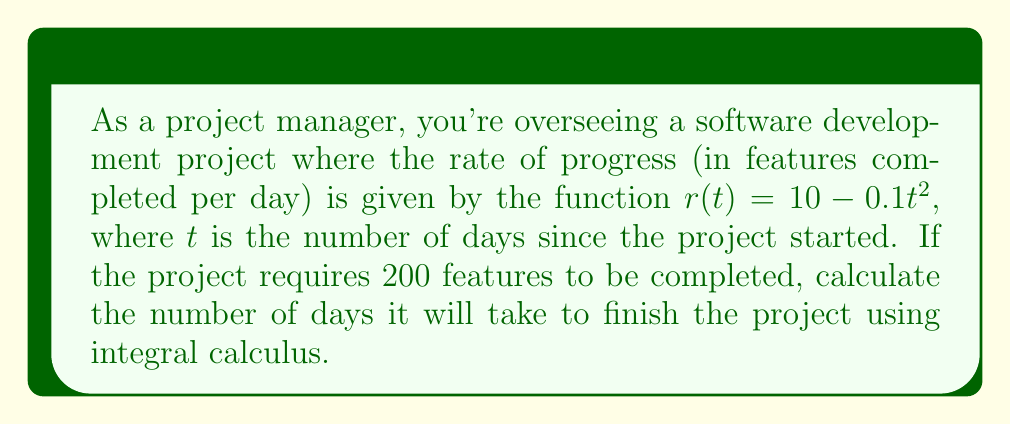Solve this math problem. To solve this problem, we need to use integral calculus to find the total number of features completed over time and then determine when this total reaches 200.

1. The rate of progress is given by $r(t) = 10 - 0.1t^2$ features per day.

2. To find the total number of features completed up to time $T$, we need to integrate the rate function from 0 to T:

   $$F(T) = \int_0^T r(t) dt = \int_0^T (10 - 0.1t^2) dt$$

3. Integrating this function:

   $$F(T) = [10t - \frac{0.1t^3}{3}]_0^T = 10T - \frac{0.1T^3}{3}$$

4. We want to find T when F(T) = 200:

   $$200 = 10T - \frac{0.1T^3}{3}$$

5. Rearranging the equation:

   $$\frac{0.1T^3}{3} - 10T + 200 = 0$$

   $$\frac{T^3}{30} - 10T + 200 = 0$$

6. This cubic equation doesn't have a simple analytical solution. We need to solve it numerically or graphically.

7. Using a numerical method (e.g., Newton-Raphson) or a graphing calculator, we can find that the solution is approximately T ≈ 22.05 days.
Answer: The project will take approximately 22.05 days to complete. 